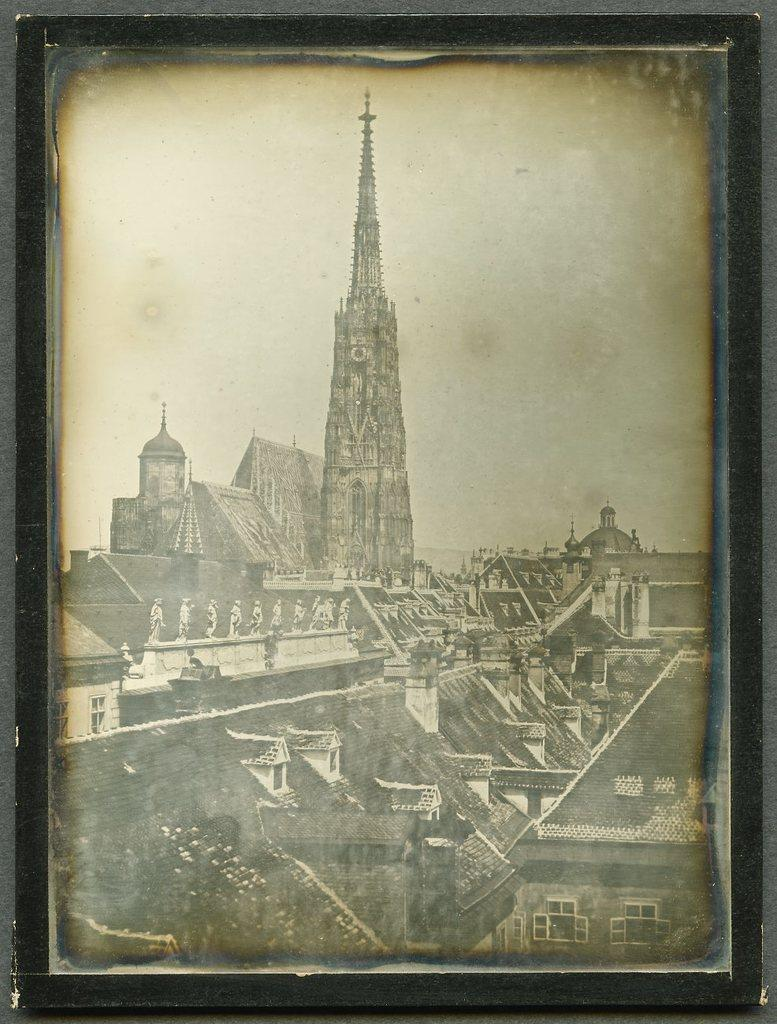What object is present in the image that holds images? There is a photo frame in the image that holds images. What type of images are contained within the photo frame? The photo frame contains images of many buildings. How many bushes are visible in the photo frame? There are no bushes visible in the photo frame; it contains images of many buildings. 